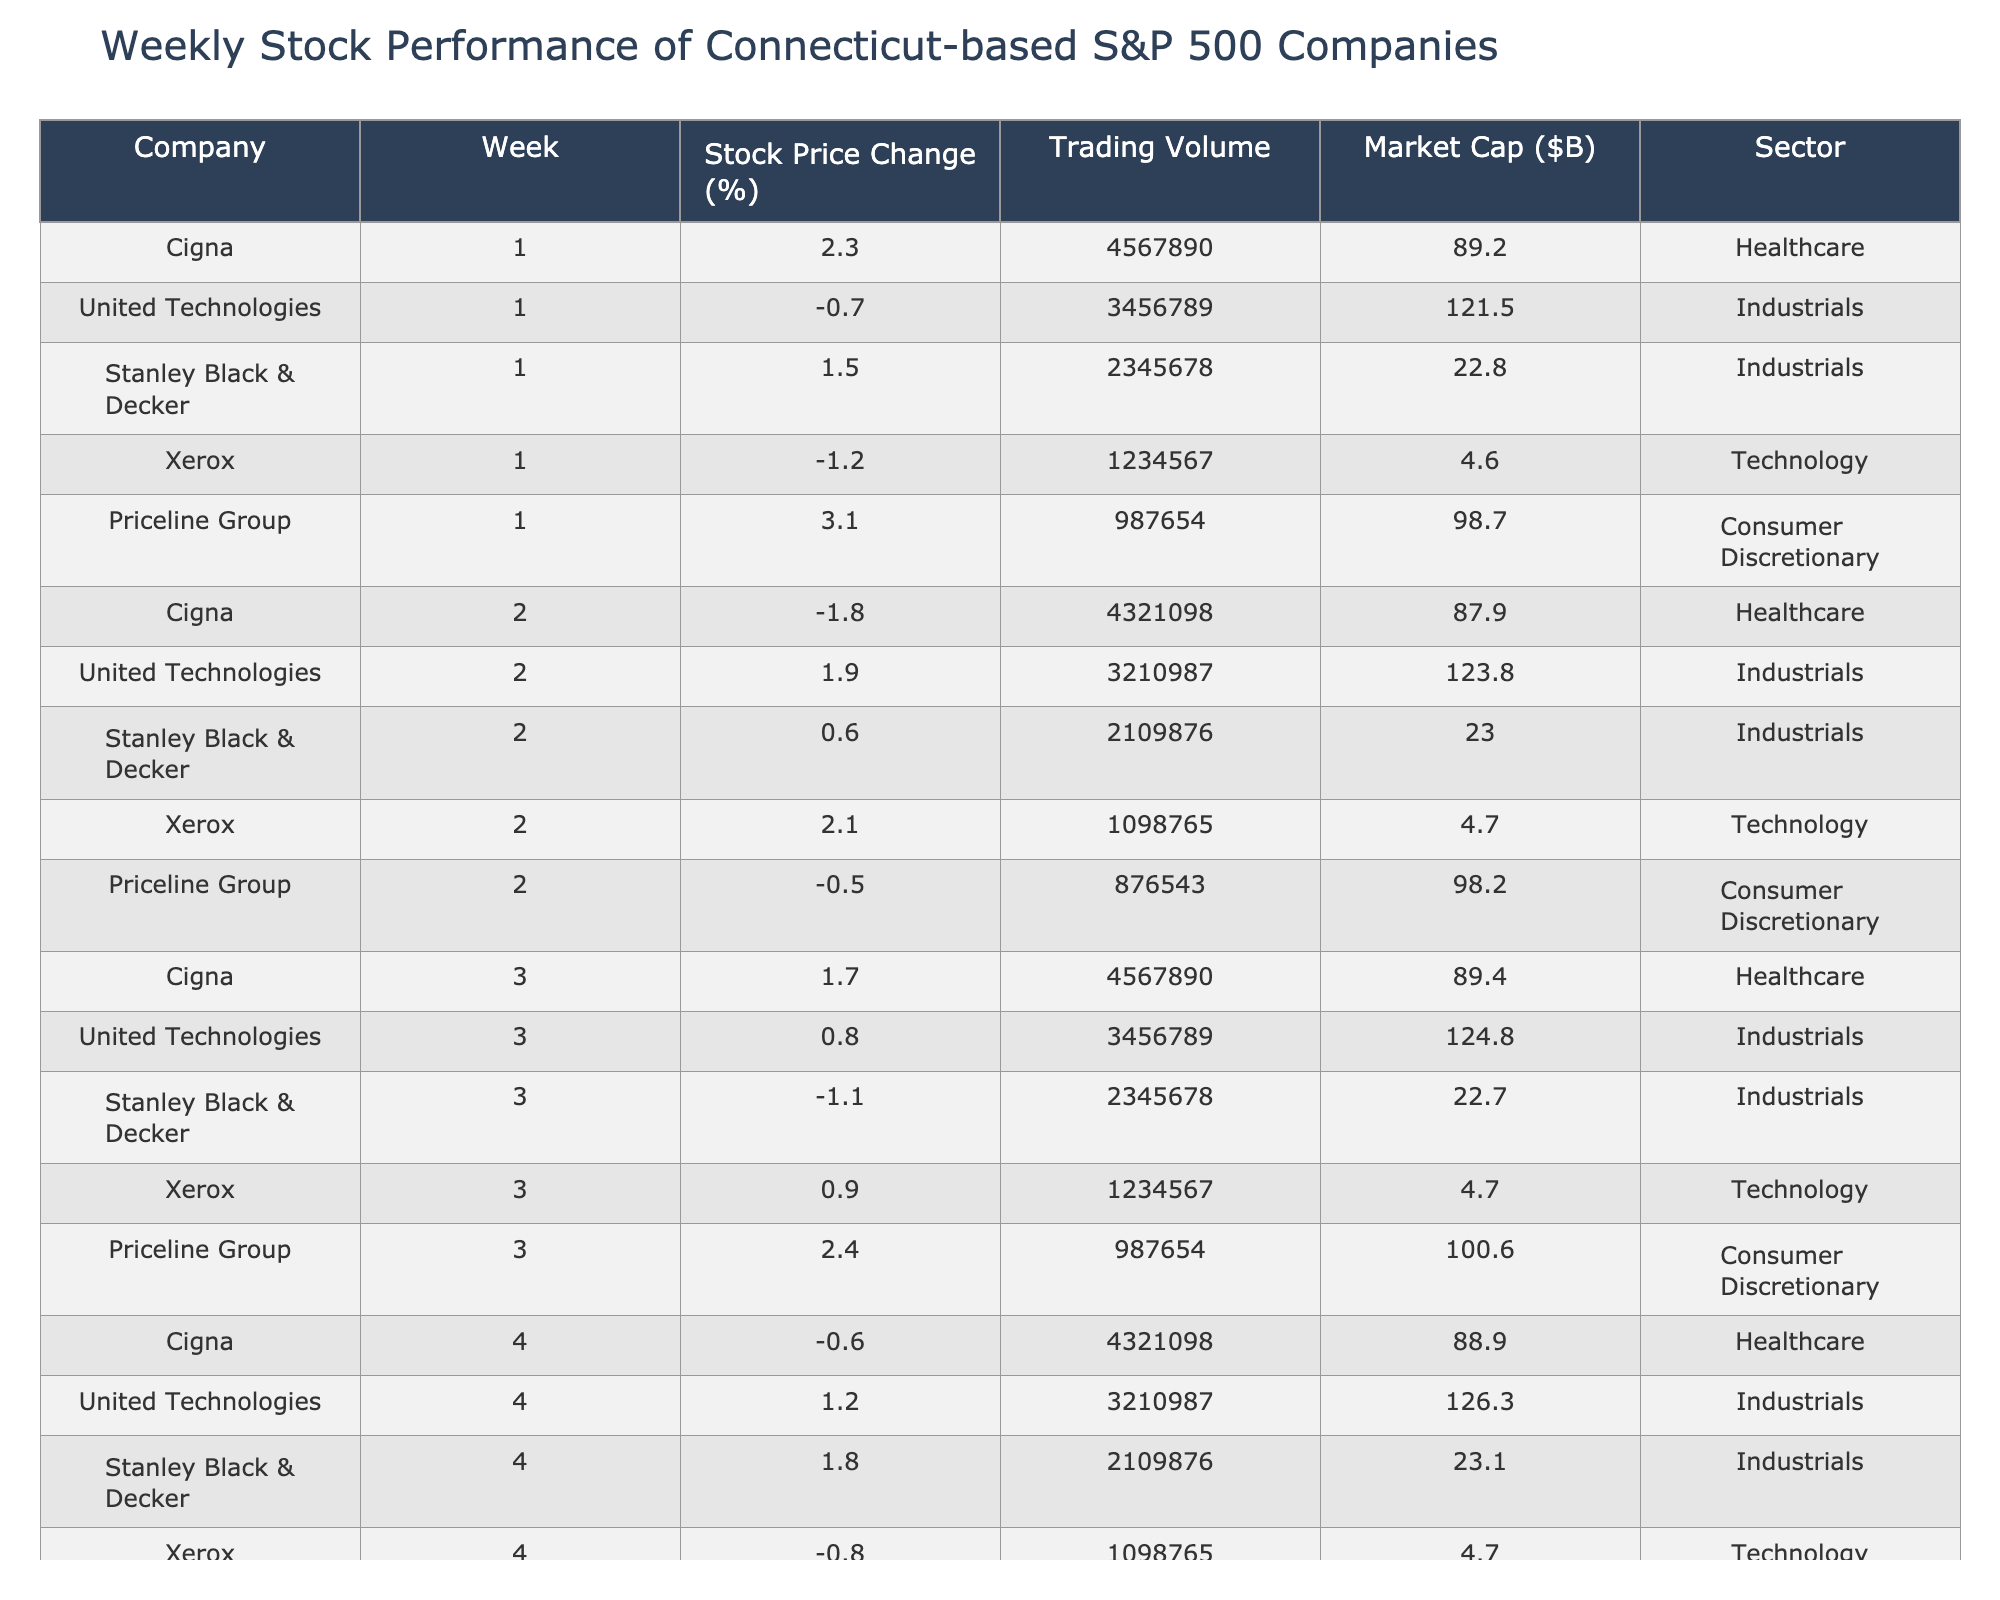What was the stock price change percentage for United Technologies in week 2? According to the table, United Technologies had a stock price change of 1.9% in week 2.
Answer: 1.9% Which company had the highest stock price change in week 1? Looking at the table for week 1, the highest stock price change was for Priceline Group at 3.1%.
Answer: Priceline Group What is the total stock price change percentage for Cigna over the first four weeks? Cigna's weekly stock price changes are 2.3%, -1.8%, 1.7%, and -0.6%. When summed up (2.3 - 1.8 + 1.7 - 0.6) the total is 1.6%.
Answer: 1.6% Did Stanley Black & Decker see a positive stock price change in week 3? By consulting the table, Stanley Black & Decker's stock price change in week 3 was -1.1%, which is negative.
Answer: No What was the average trading volume for Xerox over the four weeks? The trading volumes for Xerox are 1,234,567 in week 1, 1,098,765 in week 2, 1,234,567 in week 3, and 1,098,765 in week 4. The total trading volume is 4,666,864, and with 4 weeks, the average is 4,666,864/4 = 1,166,716.
Answer: 1,166,716 Which sector did Priceline Group belong to, and did it have the highest market cap among its peers? Priceline Group belongs to the Consumer Discretionary sector. Comparing the market caps of the companies, Priceline Group's market cap was 98.7 billion, which is lower than United Technologies at 121.5 billion.
Answer: No What was the overall trend for United Technologies over the four weeks? By inspecting the table, the stock price changes for United Technologies were -0.7%, 1.9%, 0.8%, and 1.2%. The positive changes outnumber the negative, indicating an overall upward trend.
Answer: Upward trend Which company had the lowest market capitalization among the listed companies? From the table, Xerox had the lowest market cap at $4.6 billion.
Answer: Xerox 